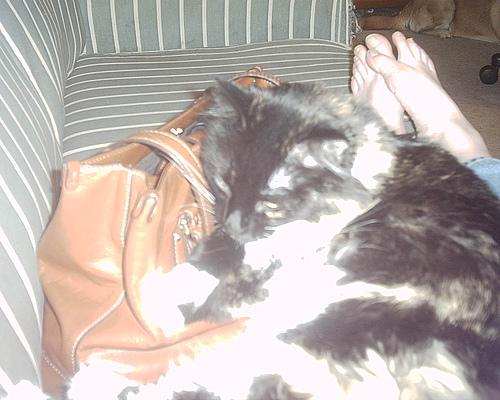Where does the cat rest?

Choices:
A) cat house
B) couch
C) mattress
D) dog house couch 